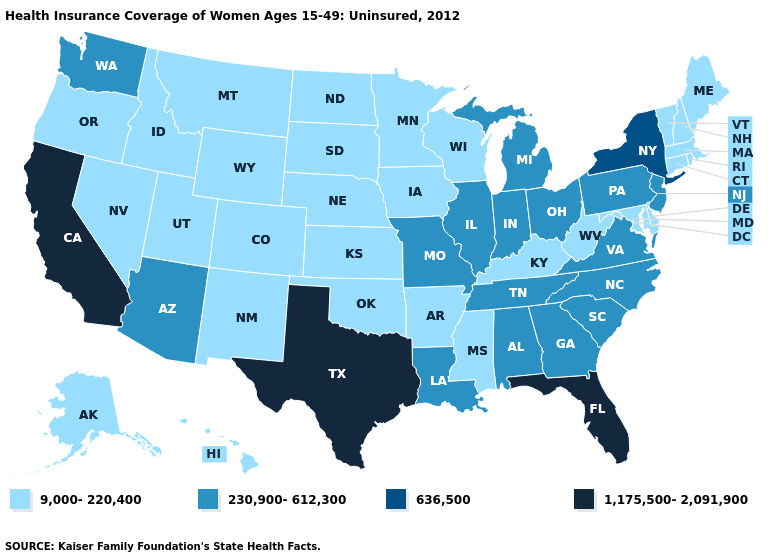What is the value of Massachusetts?
Quick response, please. 9,000-220,400. Is the legend a continuous bar?
Keep it brief. No. Among the states that border Minnesota , which have the lowest value?
Quick response, please. Iowa, North Dakota, South Dakota, Wisconsin. Name the states that have a value in the range 1,175,500-2,091,900?
Give a very brief answer. California, Florida, Texas. Name the states that have a value in the range 636,500?
Keep it brief. New York. Does Iowa have the lowest value in the MidWest?
Give a very brief answer. Yes. Among the states that border Virginia , does North Carolina have the highest value?
Be succinct. Yes. What is the value of Texas?
Keep it brief. 1,175,500-2,091,900. What is the lowest value in the USA?
Be succinct. 9,000-220,400. Name the states that have a value in the range 230,900-612,300?
Quick response, please. Alabama, Arizona, Georgia, Illinois, Indiana, Louisiana, Michigan, Missouri, New Jersey, North Carolina, Ohio, Pennsylvania, South Carolina, Tennessee, Virginia, Washington. What is the value of Colorado?
Be succinct. 9,000-220,400. Among the states that border Connecticut , which have the lowest value?
Keep it brief. Massachusetts, Rhode Island. Does the map have missing data?
Short answer required. No. Name the states that have a value in the range 9,000-220,400?
Short answer required. Alaska, Arkansas, Colorado, Connecticut, Delaware, Hawaii, Idaho, Iowa, Kansas, Kentucky, Maine, Maryland, Massachusetts, Minnesota, Mississippi, Montana, Nebraska, Nevada, New Hampshire, New Mexico, North Dakota, Oklahoma, Oregon, Rhode Island, South Dakota, Utah, Vermont, West Virginia, Wisconsin, Wyoming. Name the states that have a value in the range 230,900-612,300?
Concise answer only. Alabama, Arizona, Georgia, Illinois, Indiana, Louisiana, Michigan, Missouri, New Jersey, North Carolina, Ohio, Pennsylvania, South Carolina, Tennessee, Virginia, Washington. 